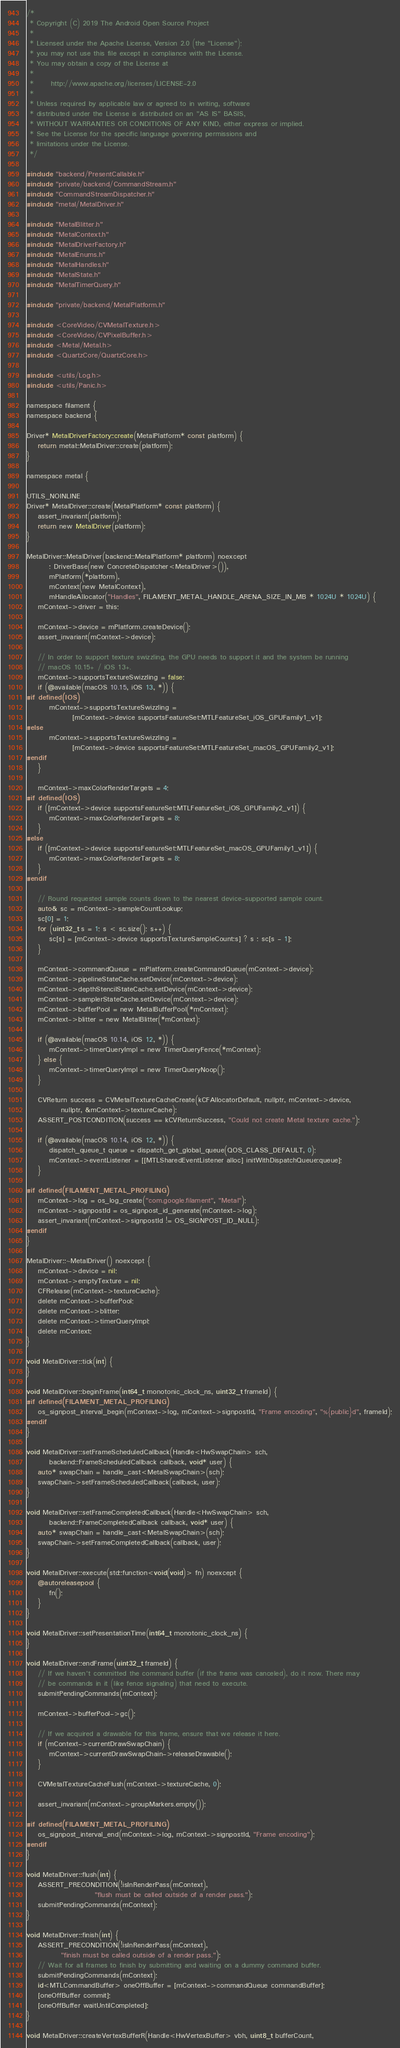Convert code to text. <code><loc_0><loc_0><loc_500><loc_500><_ObjectiveC_>/*
 * Copyright (C) 2019 The Android Open Source Project
 *
 * Licensed under the Apache License, Version 2.0 (the "License");
 * you may not use this file except in compliance with the License.
 * You may obtain a copy of the License at
 *
 *      http://www.apache.org/licenses/LICENSE-2.0
 *
 * Unless required by applicable law or agreed to in writing, software
 * distributed under the License is distributed on an "AS IS" BASIS,
 * WITHOUT WARRANTIES OR CONDITIONS OF ANY KIND, either express or implied.
 * See the License for the specific language governing permissions and
 * limitations under the License.
 */

#include "backend/PresentCallable.h"
#include "private/backend/CommandStream.h"
#include "CommandStreamDispatcher.h"
#include "metal/MetalDriver.h"

#include "MetalBlitter.h"
#include "MetalContext.h"
#include "MetalDriverFactory.h"
#include "MetalEnums.h"
#include "MetalHandles.h"
#include "MetalState.h"
#include "MetalTimerQuery.h"

#include "private/backend/MetalPlatform.h"

#include <CoreVideo/CVMetalTexture.h>
#include <CoreVideo/CVPixelBuffer.h>
#include <Metal/Metal.h>
#include <QuartzCore/QuartzCore.h>

#include <utils/Log.h>
#include <utils/Panic.h>

namespace filament {
namespace backend {

Driver* MetalDriverFactory::create(MetalPlatform* const platform) {
    return metal::MetalDriver::create(platform);
}

namespace metal {

UTILS_NOINLINE
Driver* MetalDriver::create(MetalPlatform* const platform) {
    assert_invariant(platform);
    return new MetalDriver(platform);
}

MetalDriver::MetalDriver(backend::MetalPlatform* platform) noexcept
        : DriverBase(new ConcreteDispatcher<MetalDriver>()),
        mPlatform(*platform),
        mContext(new MetalContext),
        mHandleAllocator("Handles", FILAMENT_METAL_HANDLE_ARENA_SIZE_IN_MB * 1024U * 1024U) {
    mContext->driver = this;

    mContext->device = mPlatform.createDevice();
    assert_invariant(mContext->device);

    // In order to support texture swizzling, the GPU needs to support it and the system be running
    // macOS 10.15+ / iOS 13+.
    mContext->supportsTextureSwizzling = false;
    if (@available(macOS 10.15, iOS 13, *)) {
#if defined(IOS)
        mContext->supportsTextureSwizzling =
                [mContext->device supportsFeatureSet:MTLFeatureSet_iOS_GPUFamily1_v1];
#else
        mContext->supportsTextureSwizzling =
                [mContext->device supportsFeatureSet:MTLFeatureSet_macOS_GPUFamily2_v1];
#endif
    }

    mContext->maxColorRenderTargets = 4;
#if defined(IOS)
    if ([mContext->device supportsFeatureSet:MTLFeatureSet_iOS_GPUFamily2_v1]) {
        mContext->maxColorRenderTargets = 8;
    }
#else
    if ([mContext->device supportsFeatureSet:MTLFeatureSet_macOS_GPUFamily1_v1]) {
        mContext->maxColorRenderTargets = 8;
    }
#endif

    // Round requested sample counts down to the nearest device-supported sample count.
    auto& sc = mContext->sampleCountLookup;
    sc[0] = 1;
    for (uint32_t s = 1; s < sc.size(); s++) {
        sc[s] = [mContext->device supportsTextureSampleCount:s] ? s : sc[s - 1];
    }

    mContext->commandQueue = mPlatform.createCommandQueue(mContext->device);
    mContext->pipelineStateCache.setDevice(mContext->device);
    mContext->depthStencilStateCache.setDevice(mContext->device);
    mContext->samplerStateCache.setDevice(mContext->device);
    mContext->bufferPool = new MetalBufferPool(*mContext);
    mContext->blitter = new MetalBlitter(*mContext);

    if (@available(macOS 10.14, iOS 12, *)) {
        mContext->timerQueryImpl = new TimerQueryFence(*mContext);
    } else {
        mContext->timerQueryImpl = new TimerQueryNoop();
    }

    CVReturn success = CVMetalTextureCacheCreate(kCFAllocatorDefault, nullptr, mContext->device,
            nullptr, &mContext->textureCache);
    ASSERT_POSTCONDITION(success == kCVReturnSuccess, "Could not create Metal texture cache.");

    if (@available(macOS 10.14, iOS 12, *)) {
        dispatch_queue_t queue = dispatch_get_global_queue(QOS_CLASS_DEFAULT, 0);
        mContext->eventListener = [[MTLSharedEventListener alloc] initWithDispatchQueue:queue];
    }

#if defined(FILAMENT_METAL_PROFILING)
    mContext->log = os_log_create("com.google.filament", "Metal");
    mContext->signpostId = os_signpost_id_generate(mContext->log);
    assert_invariant(mContext->signpostId != OS_SIGNPOST_ID_NULL);
#endif
}

MetalDriver::~MetalDriver() noexcept {
    mContext->device = nil;
    mContext->emptyTexture = nil;
    CFRelease(mContext->textureCache);
    delete mContext->bufferPool;
    delete mContext->blitter;
    delete mContext->timerQueryImpl;
    delete mContext;
}

void MetalDriver::tick(int) {
}

void MetalDriver::beginFrame(int64_t monotonic_clock_ns, uint32_t frameId) {
#if defined(FILAMENT_METAL_PROFILING)
    os_signpost_interval_begin(mContext->log, mContext->signpostId, "Frame encoding", "%{public}d", frameId);
#endif
}

void MetalDriver::setFrameScheduledCallback(Handle<HwSwapChain> sch,
        backend::FrameScheduledCallback callback, void* user) {
    auto* swapChain = handle_cast<MetalSwapChain>(sch);
    swapChain->setFrameScheduledCallback(callback, user);
}

void MetalDriver::setFrameCompletedCallback(Handle<HwSwapChain> sch,
        backend::FrameCompletedCallback callback, void* user) {
    auto* swapChain = handle_cast<MetalSwapChain>(sch);
    swapChain->setFrameCompletedCallback(callback, user);
}

void MetalDriver::execute(std::function<void(void)> fn) noexcept {
    @autoreleasepool {
        fn();
    }
}

void MetalDriver::setPresentationTime(int64_t monotonic_clock_ns) {
}

void MetalDriver::endFrame(uint32_t frameId) {
    // If we haven't committed the command buffer (if the frame was canceled), do it now. There may
    // be commands in it (like fence signaling) that need to execute.
    submitPendingCommands(mContext);

    mContext->bufferPool->gc();

    // If we acquired a drawable for this frame, ensure that we release it here.
    if (mContext->currentDrawSwapChain) {
        mContext->currentDrawSwapChain->releaseDrawable();
    }

    CVMetalTextureCacheFlush(mContext->textureCache, 0);

    assert_invariant(mContext->groupMarkers.empty());

#if defined(FILAMENT_METAL_PROFILING)
    os_signpost_interval_end(mContext->log, mContext->signpostId, "Frame encoding");
#endif
}

void MetalDriver::flush(int) {
    ASSERT_PRECONDITION(!isInRenderPass(mContext),
                        "flush must be called outside of a render pass.");
    submitPendingCommands(mContext);
}

void MetalDriver::finish(int) {
    ASSERT_PRECONDITION(!isInRenderPass(mContext),
            "finish must be called outside of a render pass.");
    // Wait for all frames to finish by submitting and waiting on a dummy command buffer.
    submitPendingCommands(mContext);
    id<MTLCommandBuffer> oneOffBuffer = [mContext->commandQueue commandBuffer];
    [oneOffBuffer commit];
    [oneOffBuffer waitUntilCompleted];
}

void MetalDriver::createVertexBufferR(Handle<HwVertexBuffer> vbh, uint8_t bufferCount,</code> 